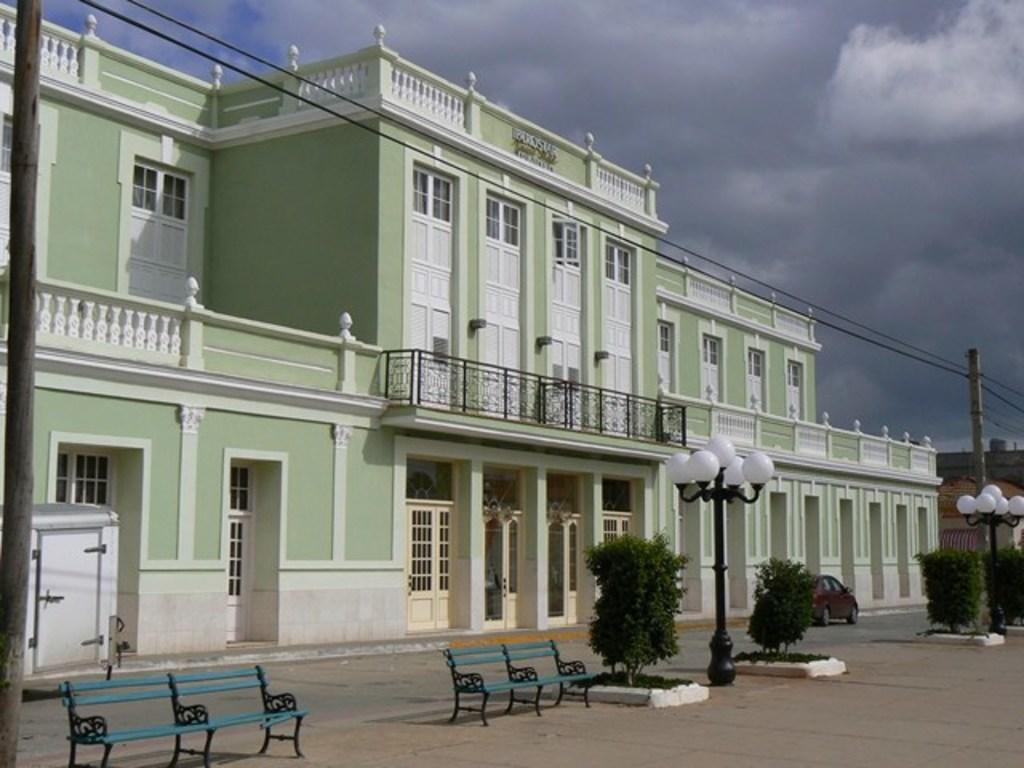In one or two sentences, can you explain what this image depicts? In the center of the image we can see building. At the bottom of the image we can see street lights, plants, car, road and benches. On the left side of the image we can see pole. In the background we can see sky and clouds. 